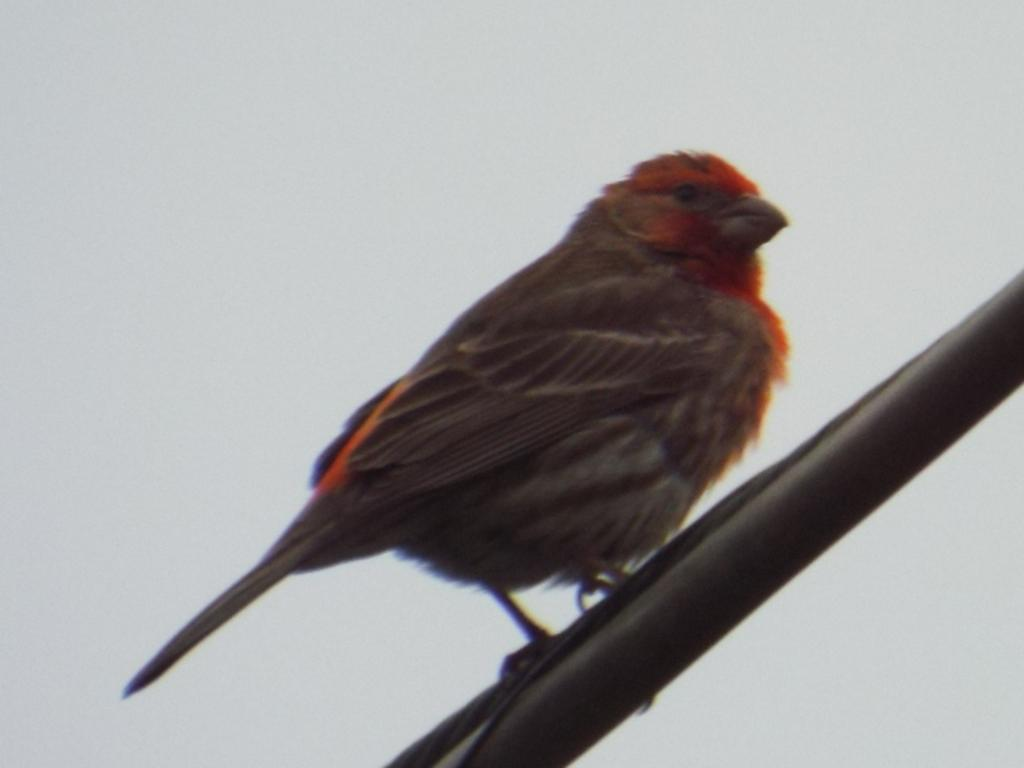What is on the pole in the image? There is a bird on the pole. What else can be seen on the pole? There is a wire on the pole. What is visible at the top of the image? The sky is visible at the top of the image. Where is the jail located in the image? There is no jail present in the image. How does the bird twist around the wire on the pole? The bird is not twisting around the wire in the image; it is perched on the pole. 